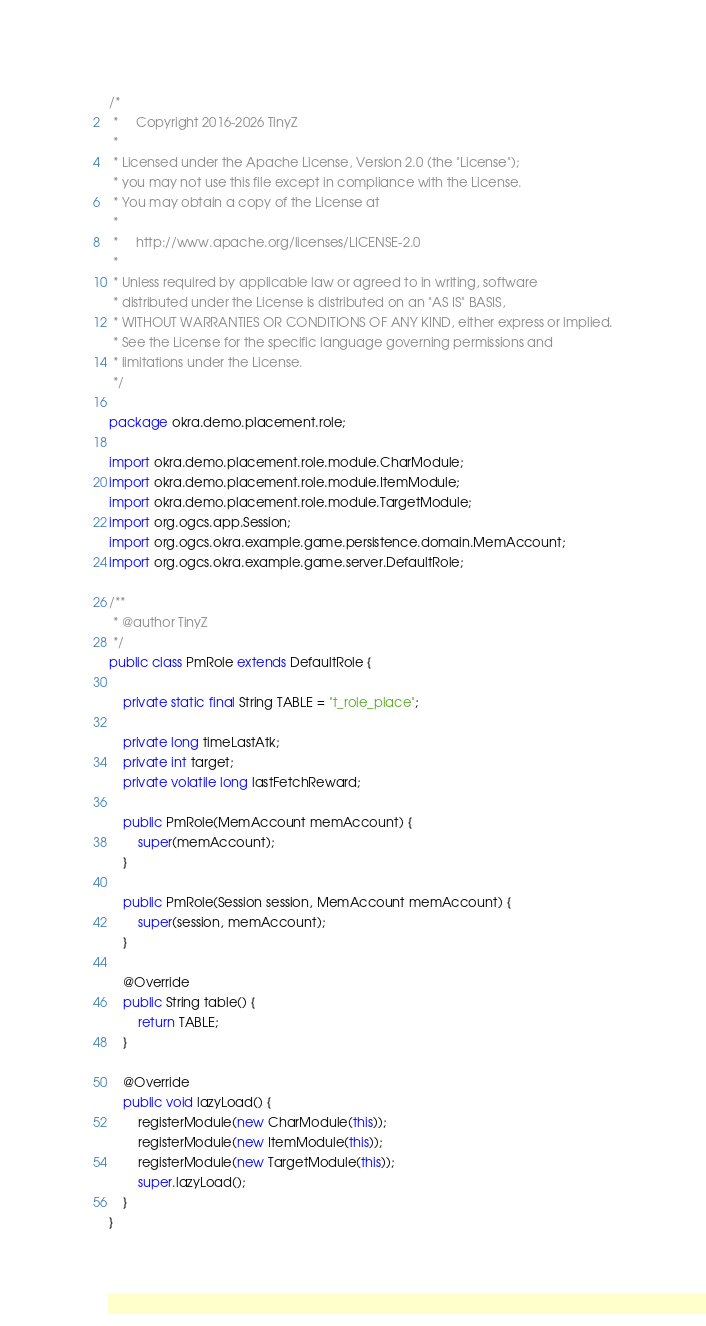<code> <loc_0><loc_0><loc_500><loc_500><_Java_>/*
 *     Copyright 2016-2026 TinyZ
 *
 * Licensed under the Apache License, Version 2.0 (the "License");
 * you may not use this file except in compliance with the License.
 * You may obtain a copy of the License at
 *
 *     http://www.apache.org/licenses/LICENSE-2.0
 *
 * Unless required by applicable law or agreed to in writing, software
 * distributed under the License is distributed on an "AS IS" BASIS,
 * WITHOUT WARRANTIES OR CONDITIONS OF ANY KIND, either express or implied.
 * See the License for the specific language governing permissions and
 * limitations under the License.
 */

package okra.demo.placement.role;

import okra.demo.placement.role.module.CharModule;
import okra.demo.placement.role.module.ItemModule;
import okra.demo.placement.role.module.TargetModule;
import org.ogcs.app.Session;
import org.ogcs.okra.example.game.persistence.domain.MemAccount;
import org.ogcs.okra.example.game.server.DefaultRole;

/**
 * @author TinyZ
 */
public class PmRole extends DefaultRole {

    private static final String TABLE = "t_role_place";

    private long timeLastAtk;
    private int target;
    private volatile long lastFetchReward;

    public PmRole(MemAccount memAccount) {
        super(memAccount);
    }

    public PmRole(Session session, MemAccount memAccount) {
        super(session, memAccount);
    }

    @Override
    public String table() {
        return TABLE;
    }

    @Override
    public void lazyLoad() {
        registerModule(new CharModule(this));
        registerModule(new ItemModule(this));
        registerModule(new TargetModule(this));
        super.lazyLoad();
    }
}
</code> 